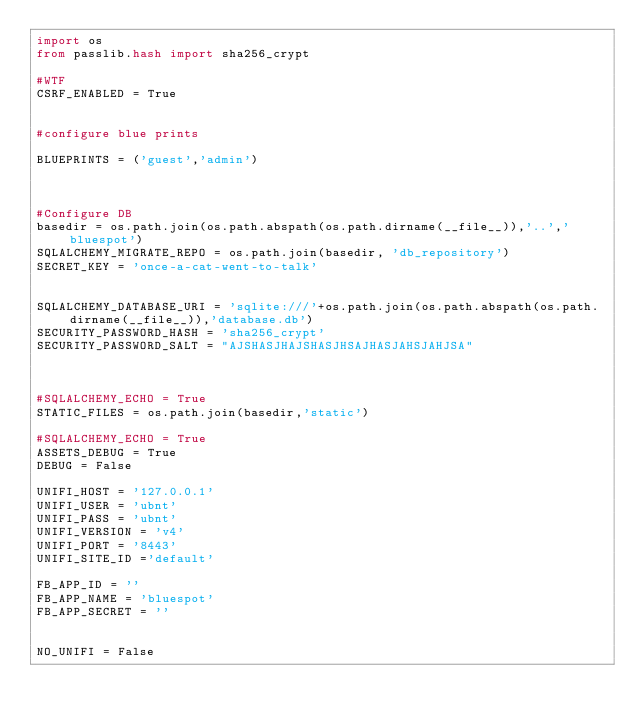Convert code to text. <code><loc_0><loc_0><loc_500><loc_500><_Python_>import os
from passlib.hash import sha256_crypt

#WTF
CSRF_ENABLED = True


#configure blue prints 

BLUEPRINTS = ('guest','admin')



#Configure DB
basedir = os.path.join(os.path.abspath(os.path.dirname(__file__)),'..','bluespot')
SQLALCHEMY_MIGRATE_REPO = os.path.join(basedir, 'db_repository')
SECRET_KEY = 'once-a-cat-went-to-talk'


SQLALCHEMY_DATABASE_URI = 'sqlite:///'+os.path.join(os.path.abspath(os.path.dirname(__file__)),'database.db')
SECURITY_PASSWORD_HASH = 'sha256_crypt'
SECURITY_PASSWORD_SALT = "AJSHASJHAJSHASJHSAJHASJAHSJAHJSA"



#SQLALCHEMY_ECHO = True
STATIC_FILES = os.path.join(basedir,'static')

#SQLALCHEMY_ECHO = True
ASSETS_DEBUG = True 
DEBUG = False

UNIFI_HOST = '127.0.0.1'
UNIFI_USER = 'ubnt'
UNIFI_PASS = 'ubnt'
UNIFI_VERSION = 'v4'
UNIFI_PORT = '8443'
UNIFI_SITE_ID ='default'

FB_APP_ID = ''
FB_APP_NAME = 'bluespot'
FB_APP_SECRET = ''


NO_UNIFI = False

</code> 